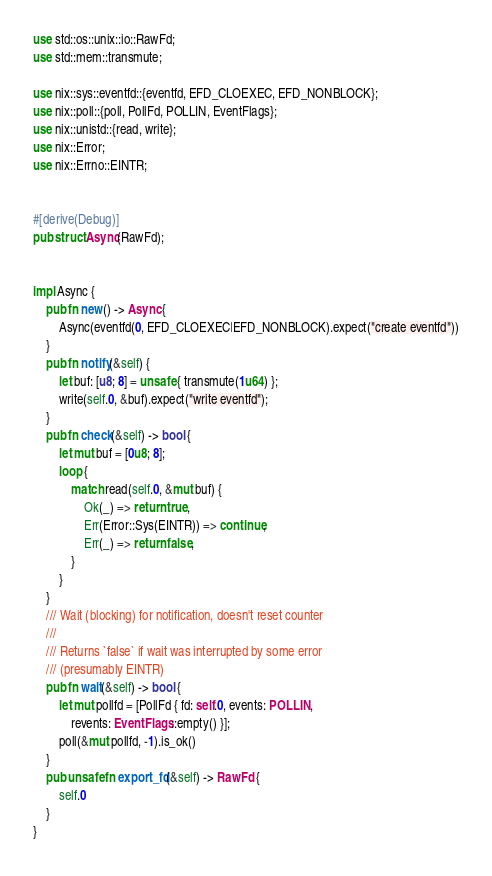Convert code to text. <code><loc_0><loc_0><loc_500><loc_500><_Rust_>use std::os::unix::io::RawFd;
use std::mem::transmute;

use nix::sys::eventfd::{eventfd, EFD_CLOEXEC, EFD_NONBLOCK};
use nix::poll::{poll, PollFd, POLLIN, EventFlags};
use nix::unistd::{read, write};
use nix::Error;
use nix::Errno::EINTR;


#[derive(Debug)]
pub struct Async(RawFd);


impl Async {
    pub fn new() -> Async {
        Async(eventfd(0, EFD_CLOEXEC|EFD_NONBLOCK).expect("create eventfd"))
    }
    pub fn notify(&self) {
        let buf: [u8; 8] = unsafe { transmute(1u64) };
        write(self.0, &buf).expect("write eventfd");
    }
    pub fn check(&self) -> bool {
        let mut buf = [0u8; 8];
        loop {
            match read(self.0, &mut buf) {
                Ok(_) => return true,
                Err(Error::Sys(EINTR)) => continue,
                Err(_) => return false,
            }
        }
    }
    /// Wait (blocking) for notification, doesn't reset counter
    ///
    /// Returns `false` if wait was interrupted by some error
    /// (presumably EINTR)
    pub fn wait(&self) -> bool {
        let mut pollfd = [PollFd { fd: self.0, events: POLLIN,
            revents: EventFlags::empty() }];
        poll(&mut pollfd, -1).is_ok()
    }
    pub unsafe fn export_fd(&self) -> RawFd {
        self.0
    }
}
</code> 